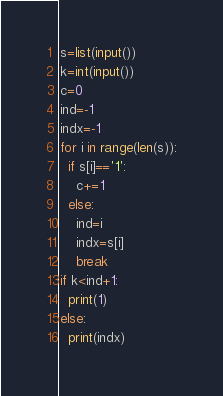Convert code to text. <code><loc_0><loc_0><loc_500><loc_500><_Python_>s=list(input())
k=int(input())
c=0
ind=-1
indx=-1
for i in range(len(s)):
  if s[i]=='1':
    c+=1
  else:
    ind=i
    indx=s[i]
    break
if k<ind+1:
  print(1)
else:
  print(indx)</code> 